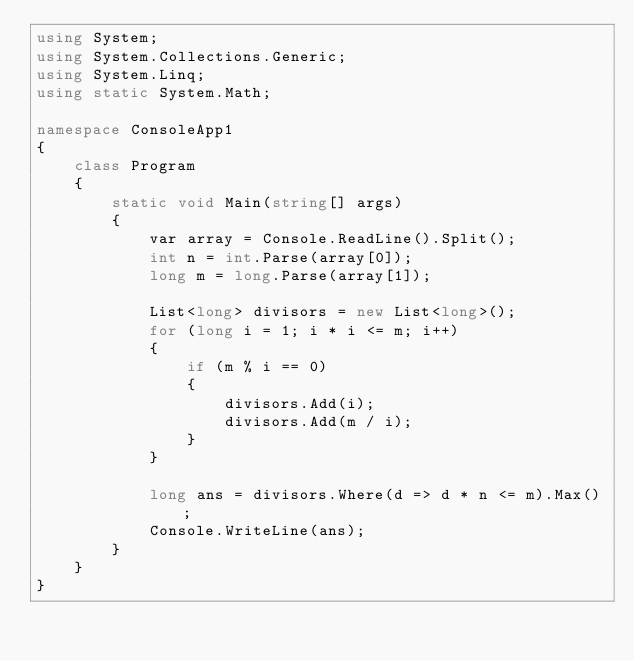Convert code to text. <code><loc_0><loc_0><loc_500><loc_500><_C#_>using System;
using System.Collections.Generic;
using System.Linq;
using static System.Math;

namespace ConsoleApp1
{
    class Program
    {
        static void Main(string[] args)
        {
            var array = Console.ReadLine().Split();
            int n = int.Parse(array[0]);
            long m = long.Parse(array[1]);

            List<long> divisors = new List<long>();
            for (long i = 1; i * i <= m; i++)
            {
                if (m % i == 0)
                {
                    divisors.Add(i);
                    divisors.Add(m / i);
                }
            }

            long ans = divisors.Where(d => d * n <= m).Max();
            Console.WriteLine(ans);
        }
    }
}</code> 